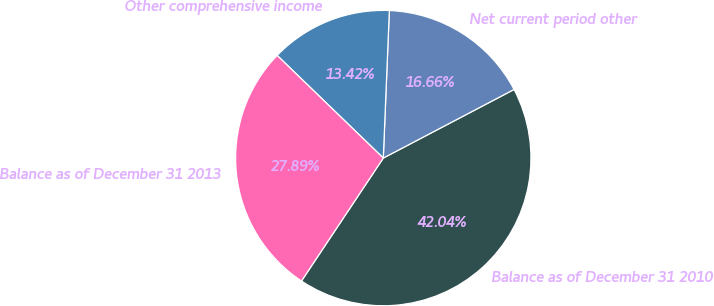<chart> <loc_0><loc_0><loc_500><loc_500><pie_chart><fcel>Balance as of December 31 2010<fcel>Net current period other<fcel>Other comprehensive income<fcel>Balance as of December 31 2013<nl><fcel>42.04%<fcel>16.66%<fcel>13.42%<fcel>27.89%<nl></chart> 